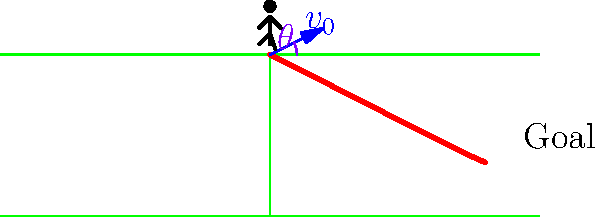In the golden era of the 70s, curved free kicks were becoming increasingly popular. Consider a player taking a free kick with an initial velocity $v_0 = 25$ m/s at an angle $\theta = 26.57°$ above the horizontal. If the ball travels a horizontal distance of 40 meters before reaching the goal, what is the time of flight for the ball, assuming no air resistance? Let's approach this step-by-step using the equations of motion for projectile motion:

1) First, we need to consider the horizontal motion. The horizontal displacement is given by:
   $$x = v_0 \cos(\theta) \cdot t$$
   Where $x$ is the horizontal displacement, $v_0$ is the initial velocity, $\theta$ is the angle, and $t$ is the time of flight.

2) We know that $x = 40$ m, $v_0 = 25$ m/s, and $\theta = 26.57°$. Let's substitute these values:
   $$40 = 25 \cos(26.57°) \cdot t$$

3) Now, let's solve for $t$:
   $$t = \frac{40}{25 \cos(26.57°)}$$

4) Using a calculator or computer, we can evaluate this:
   $$t = \frac{40}{25 \cdot 0.8944} \approx 1.79 \text{ seconds}$$

5) We can verify this using the vertical motion equation:
   $$y = v_0 \sin(\theta) \cdot t - \frac{1}{2}gt^2$$
   Where $y$ is the vertical displacement (which should be 0 at the end), and $g$ is the acceleration due to gravity (9.8 m/s²).

6) Substituting our values:
   $$0 = 25 \sin(26.57°) \cdot 1.79 - \frac{1}{2} \cdot 9.8 \cdot 1.79^2$$
   $$0 = 20.03 - 15.73$$ (approximately)

This confirms our calculation for the time of flight.
Answer: 1.79 seconds 